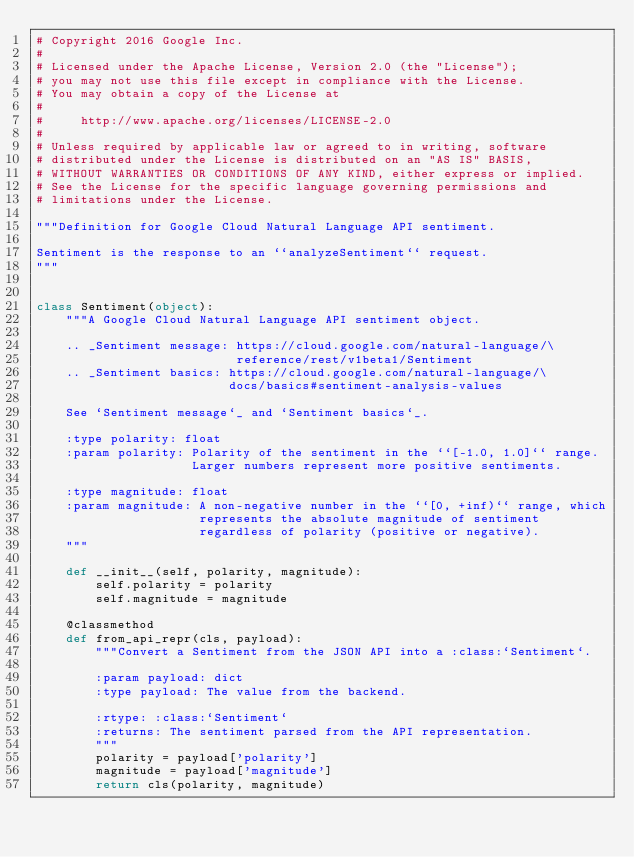<code> <loc_0><loc_0><loc_500><loc_500><_Python_># Copyright 2016 Google Inc.
#
# Licensed under the Apache License, Version 2.0 (the "License");
# you may not use this file except in compliance with the License.
# You may obtain a copy of the License at
#
#     http://www.apache.org/licenses/LICENSE-2.0
#
# Unless required by applicable law or agreed to in writing, software
# distributed under the License is distributed on an "AS IS" BASIS,
# WITHOUT WARRANTIES OR CONDITIONS OF ANY KIND, either express or implied.
# See the License for the specific language governing permissions and
# limitations under the License.

"""Definition for Google Cloud Natural Language API sentiment.

Sentiment is the response to an ``analyzeSentiment`` request.
"""


class Sentiment(object):
    """A Google Cloud Natural Language API sentiment object.

    .. _Sentiment message: https://cloud.google.com/natural-language/\
                           reference/rest/v1beta1/Sentiment
    .. _Sentiment basics: https://cloud.google.com/natural-language/\
                          docs/basics#sentiment-analysis-values

    See `Sentiment message`_ and `Sentiment basics`_.

    :type polarity: float
    :param polarity: Polarity of the sentiment in the ``[-1.0, 1.0]`` range.
                     Larger numbers represent more positive sentiments.

    :type magnitude: float
    :param magnitude: A non-negative number in the ``[0, +inf)`` range, which
                      represents the absolute magnitude of sentiment
                      regardless of polarity (positive or negative).
    """

    def __init__(self, polarity, magnitude):
        self.polarity = polarity
        self.magnitude = magnitude

    @classmethod
    def from_api_repr(cls, payload):
        """Convert a Sentiment from the JSON API into a :class:`Sentiment`.

        :param payload: dict
        :type payload: The value from the backend.

        :rtype: :class:`Sentiment`
        :returns: The sentiment parsed from the API representation.
        """
        polarity = payload['polarity']
        magnitude = payload['magnitude']
        return cls(polarity, magnitude)
</code> 